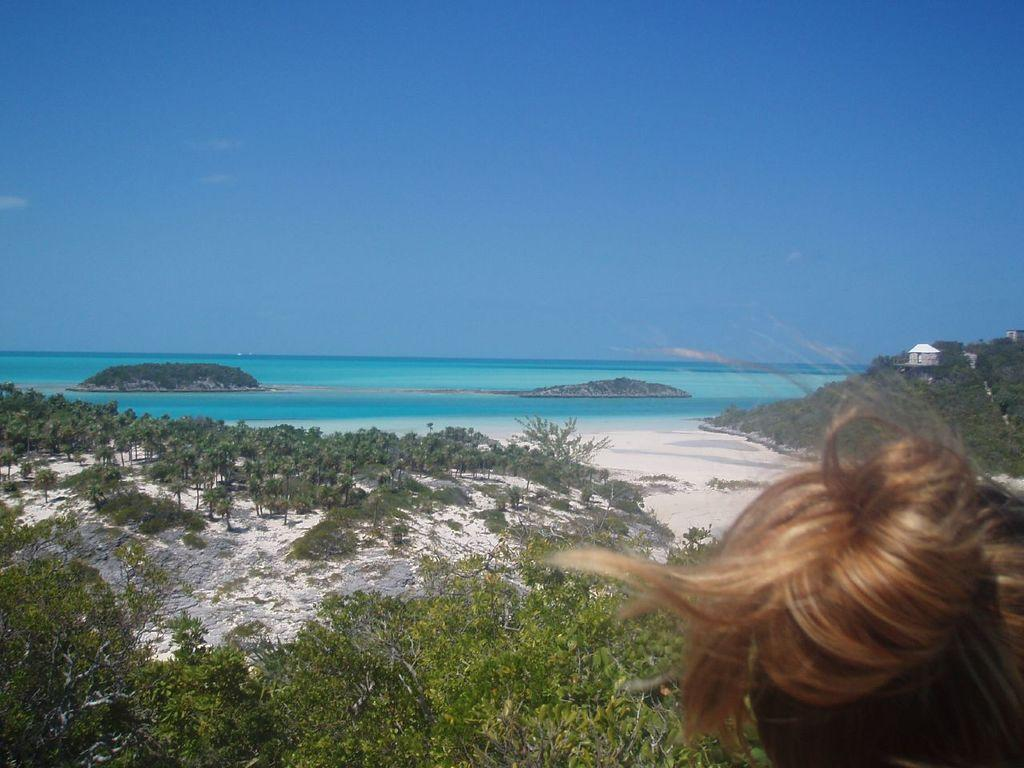What is the main subject of the image? There is a person's head in the image. What type of natural environment is depicted in the image? There are trees, plants, sand, and an island with trees in the image. What type of structure is present in the image? There is a building in the image. What is the condition of the water in the image? The water is visible in the image. What can be seen in the background of the image? The sky is visible in the background of the image. What type of oatmeal is being served on the island in the image? There is no oatmeal present in the image; it features a person's head, trees, plants, sand, a building, water, and an island with trees. Can you tell me the credit score of the person whose head is in the image? There is no information about the person's credit score in the image. 